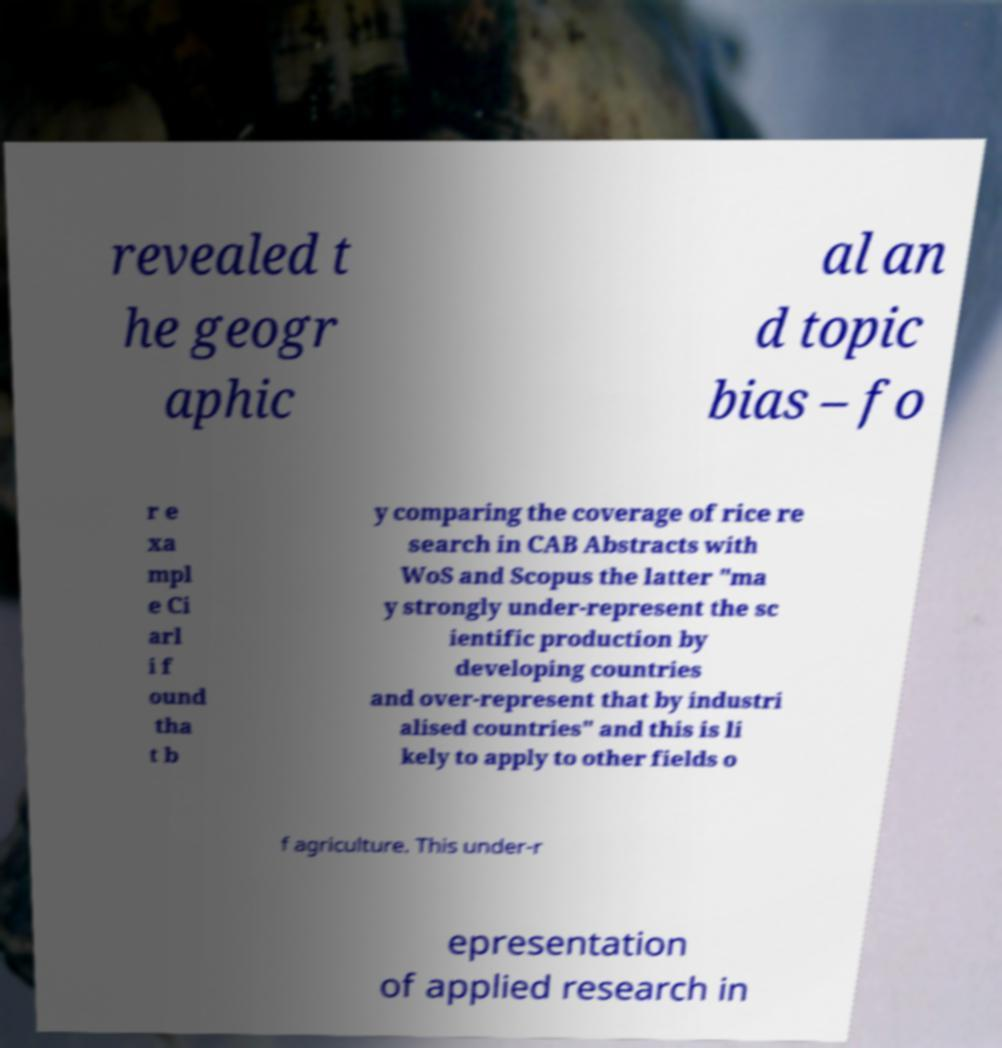There's text embedded in this image that I need extracted. Can you transcribe it verbatim? revealed t he geogr aphic al an d topic bias – fo r e xa mpl e Ci arl i f ound tha t b y comparing the coverage of rice re search in CAB Abstracts with WoS and Scopus the latter "ma y strongly under-represent the sc ientific production by developing countries and over-represent that by industri alised countries" and this is li kely to apply to other fields o f agriculture. This under-r epresentation of applied research in 